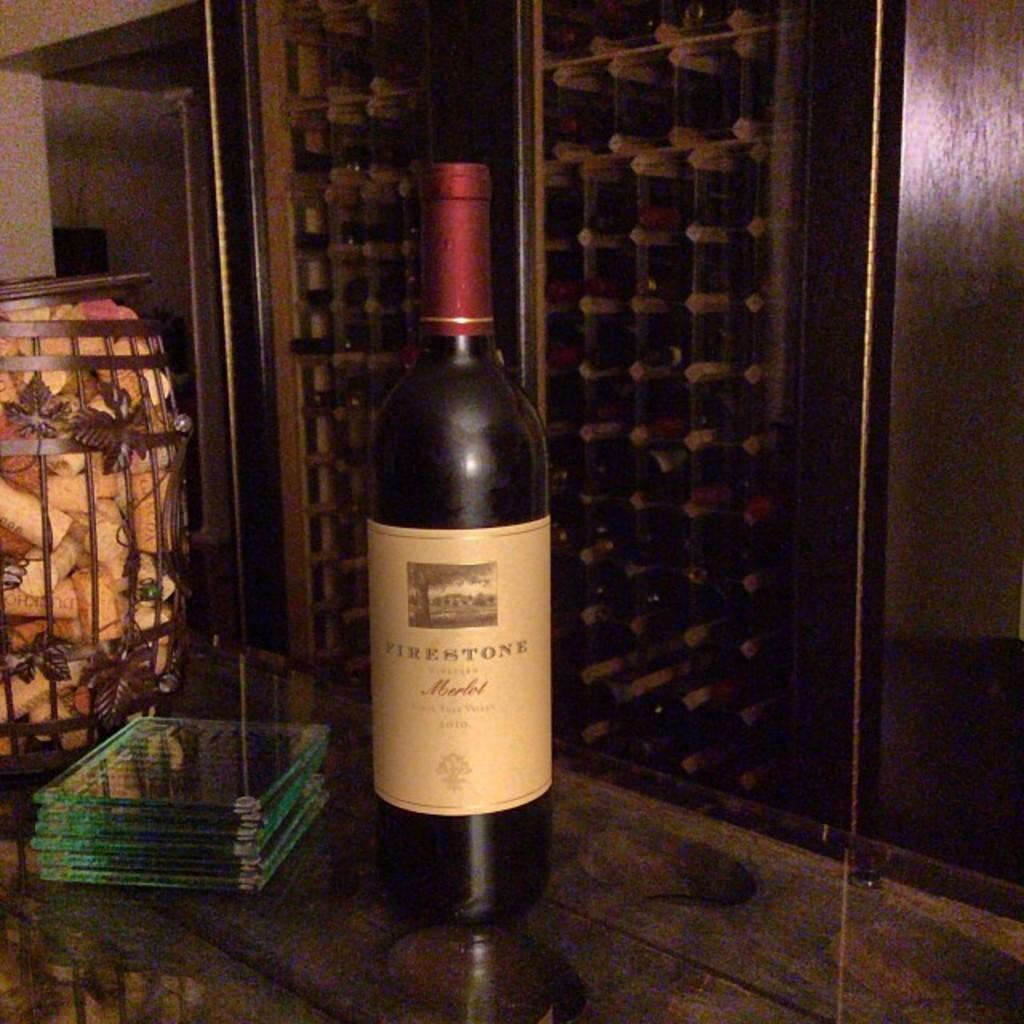<image>
Provide a brief description of the given image. A bottle of Firestone merlot wine sits on a table. 